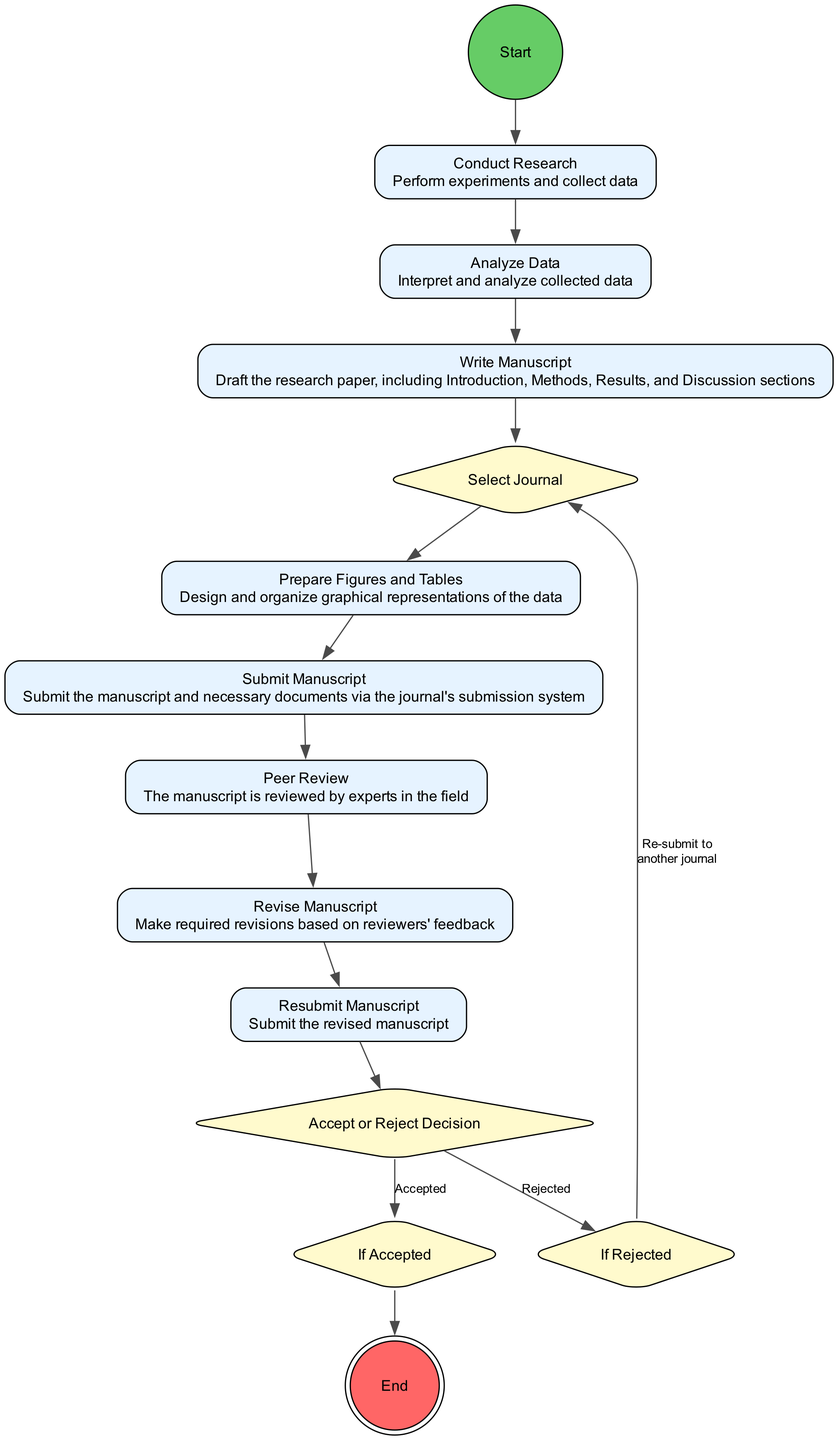What is the first activity in the diagram? The first activity in the diagram begins from the 'Start' node, which then connects to the 'Conduct Research' node, indicating that conducting research is the initial step.
Answer: Conduct Research How many decision nodes are there in the process? By examining the diagram, we can see there are three decision nodes: 'Select Journal', 'Accept or Reject Decision', and 'If Rejected'. Counting these gives a total of three decision nodes.
Answer: 3 What activity follows 'Submit Manuscript'? The 'Submit Manuscript' node connects to the 'Peer Review' node, which comes immediately after it in the sequence of activities depicted in the diagram.
Answer: Peer Review What happens if the manuscript is accepted? The flow indicates that if the manuscript is accepted, it proceeds to the 'If Accepted' decision node, which leads directly to the 'End' node, signaling that the process culminates in publication.
Answer: End Which activity comes before 'Revise Manuscript'? The diagram illustrates that 'Peer Review' is the activity that directly precedes 'Revise Manuscript', following the review process which involves feedback and revisions.
Answer: Peer Review What action must be taken if the manuscript is rejected? The diagram states that if the manuscript is rejected, the process leads to the 'If Rejected' decision node, which points back to the 'Select Journal', indicating a re-evaluation of submission options.
Answer: Select Journal What is the final outcome of the process? The 'End' node concludes the process, indicating the final outcome is that the research paper is published as a result of the steps taken in the diagram.
Answer: Research paper is published How many total activities are depicted in the diagram? The activities listed in the diagram include: 'Conduct Research', 'Analyze Data', 'Write Manuscript', 'Prepare Figures and Tables', 'Submit Manuscript', 'Peer Review', 'Revise Manuscript', and 'Resubmit Manuscript'. Counting these gives a total of eight activities.
Answer: 8 What is the purpose of the 'Prepare Figures and Tables' activity? The diagram notes that 'Prepare Figures and Tables' is an activity intended for designing and organizing graphical representations of the data, which is crucial for effective communication in the manuscript.
Answer: Design and organize graphical representations of the data 